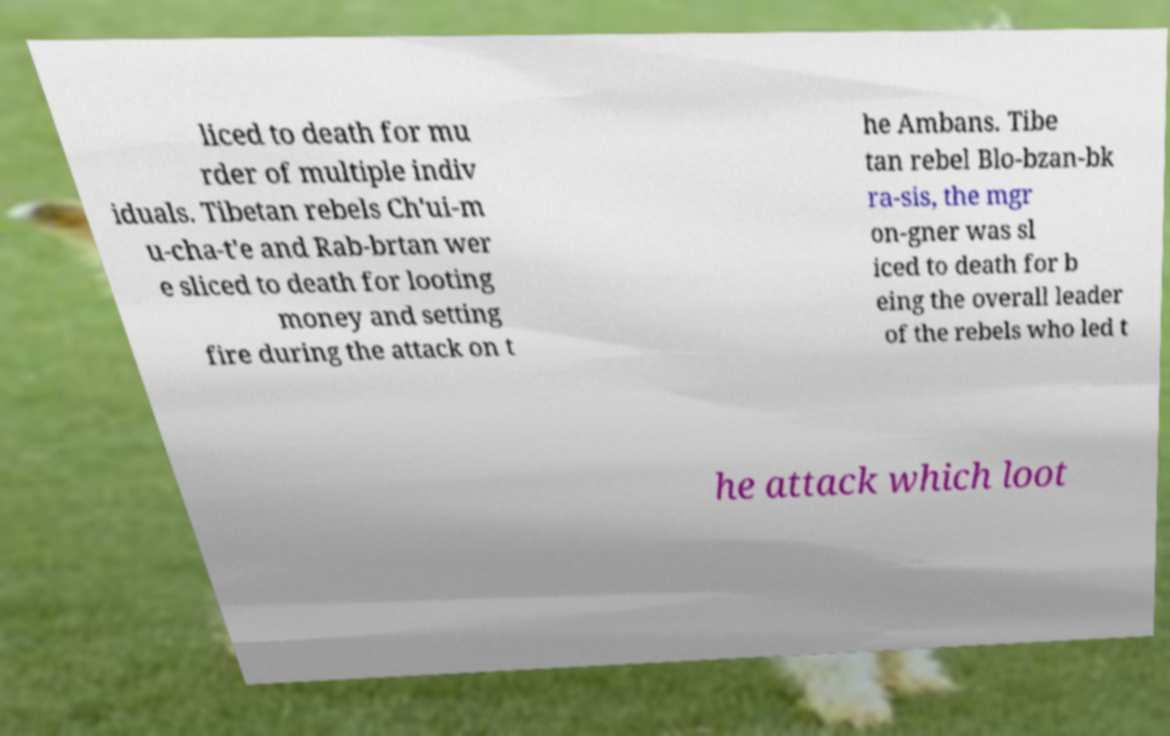I need the written content from this picture converted into text. Can you do that? liced to death for mu rder of multiple indiv iduals. Tibetan rebels Ch'ui-m u-cha-t'e and Rab-brtan wer e sliced to death for looting money and setting fire during the attack on t he Ambans. Tibe tan rebel Blo-bzan-bk ra-sis, the mgr on-gner was sl iced to death for b eing the overall leader of the rebels who led t he attack which loot 